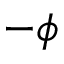Convert formula to latex. <formula><loc_0><loc_0><loc_500><loc_500>- \phi</formula> 